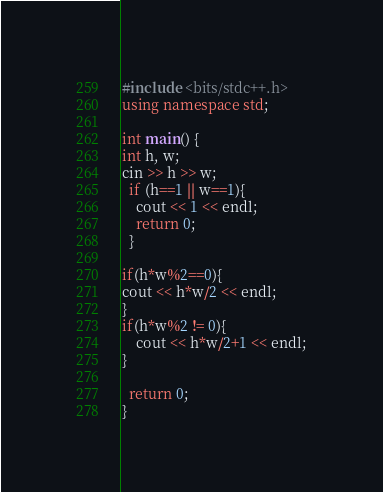<code> <loc_0><loc_0><loc_500><loc_500><_C++_>#include <bits/stdc++.h>
using namespace std;

int main() {
int h, w;
cin >> h >> w;
  if (h==1 || w==1){
    cout << 1 << endl;
    return 0;
  }

if(h*w%2==0){
cout << h*w/2 << endl;
}
if(h*w%2 != 0){
    cout << h*w/2+1 << endl;
}

  return 0;
}
</code> 